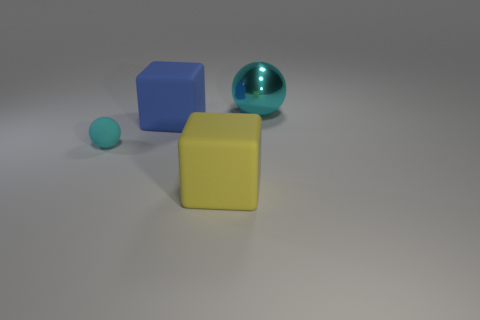There is a blue cube that is the same size as the metallic sphere; what material is it? The blue cube, which appears to be the same size as the metallic sphere, is made of a matte rubber material, which is suggested by its non-glossy texture and solid color. 